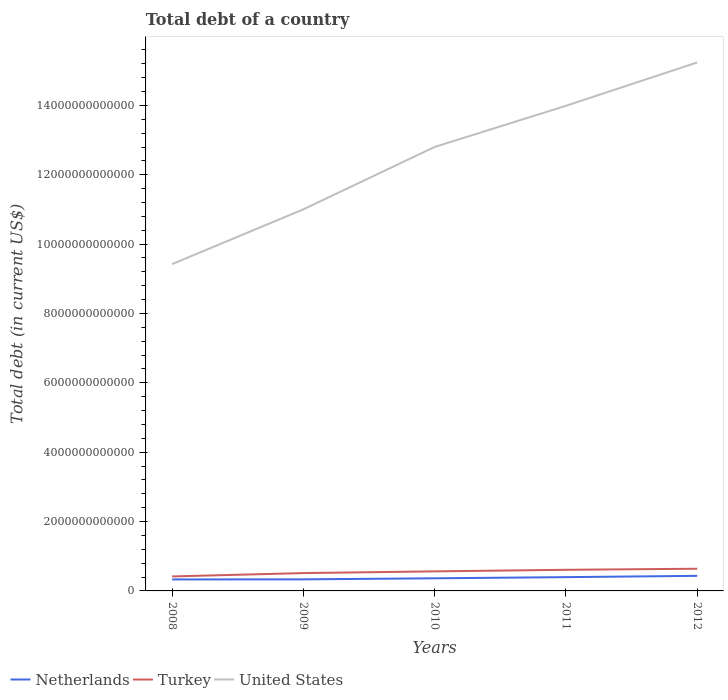How many different coloured lines are there?
Ensure brevity in your answer.  3. Across all years, what is the maximum debt in Netherlands?
Make the answer very short. 3.31e+11. What is the total debt in United States in the graph?
Give a very brief answer. -1.25e+12. What is the difference between the highest and the second highest debt in Netherlands?
Your answer should be very brief. 1.04e+11. How many years are there in the graph?
Ensure brevity in your answer.  5. What is the difference between two consecutive major ticks on the Y-axis?
Ensure brevity in your answer.  2.00e+12. Does the graph contain grids?
Your answer should be compact. No. How many legend labels are there?
Your response must be concise. 3. What is the title of the graph?
Provide a succinct answer. Total debt of a country. What is the label or title of the Y-axis?
Keep it short and to the point. Total debt (in current US$). What is the Total debt (in current US$) of Netherlands in 2008?
Give a very brief answer. 3.31e+11. What is the Total debt (in current US$) of Turkey in 2008?
Your answer should be compact. 4.18e+11. What is the Total debt (in current US$) of United States in 2008?
Your answer should be compact. 9.42e+12. What is the Total debt (in current US$) in Netherlands in 2009?
Your response must be concise. 3.33e+11. What is the Total debt (in current US$) in Turkey in 2009?
Provide a succinct answer. 5.15e+11. What is the Total debt (in current US$) of United States in 2009?
Give a very brief answer. 1.10e+13. What is the Total debt (in current US$) in Netherlands in 2010?
Your answer should be very brief. 3.64e+11. What is the Total debt (in current US$) of Turkey in 2010?
Give a very brief answer. 5.64e+11. What is the Total debt (in current US$) of United States in 2010?
Offer a terse response. 1.28e+13. What is the Total debt (in current US$) in Netherlands in 2011?
Your response must be concise. 3.97e+11. What is the Total debt (in current US$) in Turkey in 2011?
Offer a very short reply. 6.09e+11. What is the Total debt (in current US$) of United States in 2011?
Give a very brief answer. 1.40e+13. What is the Total debt (in current US$) in Netherlands in 2012?
Make the answer very short. 4.35e+11. What is the Total debt (in current US$) in Turkey in 2012?
Provide a succinct answer. 6.40e+11. What is the Total debt (in current US$) of United States in 2012?
Make the answer very short. 1.52e+13. Across all years, what is the maximum Total debt (in current US$) in Netherlands?
Keep it short and to the point. 4.35e+11. Across all years, what is the maximum Total debt (in current US$) of Turkey?
Provide a succinct answer. 6.40e+11. Across all years, what is the maximum Total debt (in current US$) in United States?
Give a very brief answer. 1.52e+13. Across all years, what is the minimum Total debt (in current US$) of Netherlands?
Offer a very short reply. 3.31e+11. Across all years, what is the minimum Total debt (in current US$) of Turkey?
Offer a terse response. 4.18e+11. Across all years, what is the minimum Total debt (in current US$) of United States?
Provide a succinct answer. 9.42e+12. What is the total Total debt (in current US$) of Netherlands in the graph?
Provide a short and direct response. 1.86e+12. What is the total Total debt (in current US$) of Turkey in the graph?
Give a very brief answer. 2.75e+12. What is the total Total debt (in current US$) in United States in the graph?
Ensure brevity in your answer.  6.25e+13. What is the difference between the Total debt (in current US$) in Netherlands in 2008 and that in 2009?
Your answer should be very brief. -1.86e+09. What is the difference between the Total debt (in current US$) of Turkey in 2008 and that in 2009?
Offer a very short reply. -9.67e+1. What is the difference between the Total debt (in current US$) in United States in 2008 and that in 2009?
Give a very brief answer. -1.58e+12. What is the difference between the Total debt (in current US$) in Netherlands in 2008 and that in 2010?
Offer a terse response. -3.28e+1. What is the difference between the Total debt (in current US$) of Turkey in 2008 and that in 2010?
Provide a short and direct response. -1.46e+11. What is the difference between the Total debt (in current US$) of United States in 2008 and that in 2010?
Give a very brief answer. -3.38e+12. What is the difference between the Total debt (in current US$) of Netherlands in 2008 and that in 2011?
Your response must be concise. -6.59e+1. What is the difference between the Total debt (in current US$) of Turkey in 2008 and that in 2011?
Make the answer very short. -1.91e+11. What is the difference between the Total debt (in current US$) of United States in 2008 and that in 2011?
Make the answer very short. -4.56e+12. What is the difference between the Total debt (in current US$) in Netherlands in 2008 and that in 2012?
Keep it short and to the point. -1.04e+11. What is the difference between the Total debt (in current US$) in Turkey in 2008 and that in 2012?
Ensure brevity in your answer.  -2.22e+11. What is the difference between the Total debt (in current US$) in United States in 2008 and that in 2012?
Give a very brief answer. -5.81e+12. What is the difference between the Total debt (in current US$) in Netherlands in 2009 and that in 2010?
Your answer should be very brief. -3.09e+1. What is the difference between the Total debt (in current US$) of Turkey in 2009 and that in 2010?
Offer a terse response. -4.96e+1. What is the difference between the Total debt (in current US$) in United States in 2009 and that in 2010?
Give a very brief answer. -1.80e+12. What is the difference between the Total debt (in current US$) of Netherlands in 2009 and that in 2011?
Your answer should be compact. -6.41e+1. What is the difference between the Total debt (in current US$) in Turkey in 2009 and that in 2011?
Offer a terse response. -9.46e+1. What is the difference between the Total debt (in current US$) in United States in 2009 and that in 2011?
Keep it short and to the point. -2.98e+12. What is the difference between the Total debt (in current US$) in Netherlands in 2009 and that in 2012?
Your answer should be compact. -1.02e+11. What is the difference between the Total debt (in current US$) in Turkey in 2009 and that in 2012?
Your answer should be compact. -1.25e+11. What is the difference between the Total debt (in current US$) in United States in 2009 and that in 2012?
Keep it short and to the point. -4.24e+12. What is the difference between the Total debt (in current US$) in Netherlands in 2010 and that in 2011?
Your answer should be very brief. -3.31e+1. What is the difference between the Total debt (in current US$) of Turkey in 2010 and that in 2011?
Offer a terse response. -4.50e+1. What is the difference between the Total debt (in current US$) of United States in 2010 and that in 2011?
Your response must be concise. -1.19e+12. What is the difference between the Total debt (in current US$) of Netherlands in 2010 and that in 2012?
Give a very brief answer. -7.08e+1. What is the difference between the Total debt (in current US$) in Turkey in 2010 and that in 2012?
Your answer should be compact. -7.55e+1. What is the difference between the Total debt (in current US$) of United States in 2010 and that in 2012?
Offer a terse response. -2.44e+12. What is the difference between the Total debt (in current US$) in Netherlands in 2011 and that in 2012?
Your response must be concise. -3.76e+1. What is the difference between the Total debt (in current US$) in Turkey in 2011 and that in 2012?
Offer a terse response. -3.05e+1. What is the difference between the Total debt (in current US$) of United States in 2011 and that in 2012?
Make the answer very short. -1.25e+12. What is the difference between the Total debt (in current US$) of Netherlands in 2008 and the Total debt (in current US$) of Turkey in 2009?
Provide a short and direct response. -1.83e+11. What is the difference between the Total debt (in current US$) of Netherlands in 2008 and the Total debt (in current US$) of United States in 2009?
Keep it short and to the point. -1.07e+13. What is the difference between the Total debt (in current US$) of Turkey in 2008 and the Total debt (in current US$) of United States in 2009?
Your answer should be very brief. -1.06e+13. What is the difference between the Total debt (in current US$) in Netherlands in 2008 and the Total debt (in current US$) in Turkey in 2010?
Keep it short and to the point. -2.33e+11. What is the difference between the Total debt (in current US$) in Netherlands in 2008 and the Total debt (in current US$) in United States in 2010?
Your answer should be compact. -1.25e+13. What is the difference between the Total debt (in current US$) in Turkey in 2008 and the Total debt (in current US$) in United States in 2010?
Offer a very short reply. -1.24e+13. What is the difference between the Total debt (in current US$) of Netherlands in 2008 and the Total debt (in current US$) of Turkey in 2011?
Your answer should be compact. -2.78e+11. What is the difference between the Total debt (in current US$) of Netherlands in 2008 and the Total debt (in current US$) of United States in 2011?
Make the answer very short. -1.37e+13. What is the difference between the Total debt (in current US$) in Turkey in 2008 and the Total debt (in current US$) in United States in 2011?
Offer a very short reply. -1.36e+13. What is the difference between the Total debt (in current US$) of Netherlands in 2008 and the Total debt (in current US$) of Turkey in 2012?
Ensure brevity in your answer.  -3.08e+11. What is the difference between the Total debt (in current US$) of Netherlands in 2008 and the Total debt (in current US$) of United States in 2012?
Keep it short and to the point. -1.49e+13. What is the difference between the Total debt (in current US$) of Turkey in 2008 and the Total debt (in current US$) of United States in 2012?
Keep it short and to the point. -1.48e+13. What is the difference between the Total debt (in current US$) of Netherlands in 2009 and the Total debt (in current US$) of Turkey in 2010?
Your answer should be compact. -2.31e+11. What is the difference between the Total debt (in current US$) in Netherlands in 2009 and the Total debt (in current US$) in United States in 2010?
Your answer should be very brief. -1.25e+13. What is the difference between the Total debt (in current US$) of Turkey in 2009 and the Total debt (in current US$) of United States in 2010?
Provide a succinct answer. -1.23e+13. What is the difference between the Total debt (in current US$) of Netherlands in 2009 and the Total debt (in current US$) of Turkey in 2011?
Your answer should be compact. -2.76e+11. What is the difference between the Total debt (in current US$) of Netherlands in 2009 and the Total debt (in current US$) of United States in 2011?
Your answer should be compact. -1.37e+13. What is the difference between the Total debt (in current US$) in Turkey in 2009 and the Total debt (in current US$) in United States in 2011?
Your answer should be compact. -1.35e+13. What is the difference between the Total debt (in current US$) of Netherlands in 2009 and the Total debt (in current US$) of Turkey in 2012?
Give a very brief answer. -3.06e+11. What is the difference between the Total debt (in current US$) of Netherlands in 2009 and the Total debt (in current US$) of United States in 2012?
Offer a very short reply. -1.49e+13. What is the difference between the Total debt (in current US$) of Turkey in 2009 and the Total debt (in current US$) of United States in 2012?
Your answer should be compact. -1.47e+13. What is the difference between the Total debt (in current US$) of Netherlands in 2010 and the Total debt (in current US$) of Turkey in 2011?
Offer a terse response. -2.45e+11. What is the difference between the Total debt (in current US$) in Netherlands in 2010 and the Total debt (in current US$) in United States in 2011?
Ensure brevity in your answer.  -1.36e+13. What is the difference between the Total debt (in current US$) of Turkey in 2010 and the Total debt (in current US$) of United States in 2011?
Provide a succinct answer. -1.34e+13. What is the difference between the Total debt (in current US$) in Netherlands in 2010 and the Total debt (in current US$) in Turkey in 2012?
Make the answer very short. -2.75e+11. What is the difference between the Total debt (in current US$) of Netherlands in 2010 and the Total debt (in current US$) of United States in 2012?
Your answer should be compact. -1.49e+13. What is the difference between the Total debt (in current US$) in Turkey in 2010 and the Total debt (in current US$) in United States in 2012?
Your response must be concise. -1.47e+13. What is the difference between the Total debt (in current US$) in Netherlands in 2011 and the Total debt (in current US$) in Turkey in 2012?
Your answer should be compact. -2.42e+11. What is the difference between the Total debt (in current US$) of Netherlands in 2011 and the Total debt (in current US$) of United States in 2012?
Ensure brevity in your answer.  -1.48e+13. What is the difference between the Total debt (in current US$) of Turkey in 2011 and the Total debt (in current US$) of United States in 2012?
Keep it short and to the point. -1.46e+13. What is the average Total debt (in current US$) in Netherlands per year?
Your answer should be compact. 3.72e+11. What is the average Total debt (in current US$) in Turkey per year?
Provide a succinct answer. 5.49e+11. What is the average Total debt (in current US$) of United States per year?
Your answer should be very brief. 1.25e+13. In the year 2008, what is the difference between the Total debt (in current US$) of Netherlands and Total debt (in current US$) of Turkey?
Keep it short and to the point. -8.65e+1. In the year 2008, what is the difference between the Total debt (in current US$) in Netherlands and Total debt (in current US$) in United States?
Your response must be concise. -9.09e+12. In the year 2008, what is the difference between the Total debt (in current US$) of Turkey and Total debt (in current US$) of United States?
Give a very brief answer. -9.01e+12. In the year 2009, what is the difference between the Total debt (in current US$) in Netherlands and Total debt (in current US$) in Turkey?
Keep it short and to the point. -1.81e+11. In the year 2009, what is the difference between the Total debt (in current US$) in Netherlands and Total debt (in current US$) in United States?
Give a very brief answer. -1.07e+13. In the year 2009, what is the difference between the Total debt (in current US$) in Turkey and Total debt (in current US$) in United States?
Provide a short and direct response. -1.05e+13. In the year 2010, what is the difference between the Total debt (in current US$) of Netherlands and Total debt (in current US$) of Turkey?
Offer a terse response. -2.00e+11. In the year 2010, what is the difference between the Total debt (in current US$) of Netherlands and Total debt (in current US$) of United States?
Provide a succinct answer. -1.24e+13. In the year 2010, what is the difference between the Total debt (in current US$) in Turkey and Total debt (in current US$) in United States?
Provide a short and direct response. -1.22e+13. In the year 2011, what is the difference between the Total debt (in current US$) of Netherlands and Total debt (in current US$) of Turkey?
Your answer should be compact. -2.12e+11. In the year 2011, what is the difference between the Total debt (in current US$) of Netherlands and Total debt (in current US$) of United States?
Your answer should be very brief. -1.36e+13. In the year 2011, what is the difference between the Total debt (in current US$) in Turkey and Total debt (in current US$) in United States?
Your response must be concise. -1.34e+13. In the year 2012, what is the difference between the Total debt (in current US$) of Netherlands and Total debt (in current US$) of Turkey?
Your answer should be compact. -2.05e+11. In the year 2012, what is the difference between the Total debt (in current US$) in Netherlands and Total debt (in current US$) in United States?
Ensure brevity in your answer.  -1.48e+13. In the year 2012, what is the difference between the Total debt (in current US$) of Turkey and Total debt (in current US$) of United States?
Provide a succinct answer. -1.46e+13. What is the ratio of the Total debt (in current US$) of Turkey in 2008 to that in 2009?
Your answer should be very brief. 0.81. What is the ratio of the Total debt (in current US$) in United States in 2008 to that in 2009?
Provide a succinct answer. 0.86. What is the ratio of the Total debt (in current US$) of Netherlands in 2008 to that in 2010?
Provide a succinct answer. 0.91. What is the ratio of the Total debt (in current US$) in Turkey in 2008 to that in 2010?
Offer a terse response. 0.74. What is the ratio of the Total debt (in current US$) in United States in 2008 to that in 2010?
Ensure brevity in your answer.  0.74. What is the ratio of the Total debt (in current US$) in Netherlands in 2008 to that in 2011?
Provide a short and direct response. 0.83. What is the ratio of the Total debt (in current US$) of Turkey in 2008 to that in 2011?
Make the answer very short. 0.69. What is the ratio of the Total debt (in current US$) in United States in 2008 to that in 2011?
Provide a succinct answer. 0.67. What is the ratio of the Total debt (in current US$) of Netherlands in 2008 to that in 2012?
Offer a very short reply. 0.76. What is the ratio of the Total debt (in current US$) of Turkey in 2008 to that in 2012?
Your response must be concise. 0.65. What is the ratio of the Total debt (in current US$) of United States in 2008 to that in 2012?
Keep it short and to the point. 0.62. What is the ratio of the Total debt (in current US$) in Netherlands in 2009 to that in 2010?
Give a very brief answer. 0.92. What is the ratio of the Total debt (in current US$) in Turkey in 2009 to that in 2010?
Your answer should be compact. 0.91. What is the ratio of the Total debt (in current US$) in United States in 2009 to that in 2010?
Give a very brief answer. 0.86. What is the ratio of the Total debt (in current US$) of Netherlands in 2009 to that in 2011?
Provide a succinct answer. 0.84. What is the ratio of the Total debt (in current US$) in Turkey in 2009 to that in 2011?
Offer a very short reply. 0.84. What is the ratio of the Total debt (in current US$) of United States in 2009 to that in 2011?
Offer a very short reply. 0.79. What is the ratio of the Total debt (in current US$) of Netherlands in 2009 to that in 2012?
Offer a terse response. 0.77. What is the ratio of the Total debt (in current US$) in Turkey in 2009 to that in 2012?
Provide a succinct answer. 0.8. What is the ratio of the Total debt (in current US$) of United States in 2009 to that in 2012?
Your response must be concise. 0.72. What is the ratio of the Total debt (in current US$) of Netherlands in 2010 to that in 2011?
Your answer should be compact. 0.92. What is the ratio of the Total debt (in current US$) of Turkey in 2010 to that in 2011?
Offer a very short reply. 0.93. What is the ratio of the Total debt (in current US$) in United States in 2010 to that in 2011?
Provide a succinct answer. 0.92. What is the ratio of the Total debt (in current US$) in Netherlands in 2010 to that in 2012?
Offer a very short reply. 0.84. What is the ratio of the Total debt (in current US$) of Turkey in 2010 to that in 2012?
Provide a succinct answer. 0.88. What is the ratio of the Total debt (in current US$) of United States in 2010 to that in 2012?
Your answer should be compact. 0.84. What is the ratio of the Total debt (in current US$) in Netherlands in 2011 to that in 2012?
Make the answer very short. 0.91. What is the ratio of the Total debt (in current US$) of Turkey in 2011 to that in 2012?
Provide a short and direct response. 0.95. What is the ratio of the Total debt (in current US$) in United States in 2011 to that in 2012?
Give a very brief answer. 0.92. What is the difference between the highest and the second highest Total debt (in current US$) of Netherlands?
Offer a very short reply. 3.76e+1. What is the difference between the highest and the second highest Total debt (in current US$) in Turkey?
Provide a succinct answer. 3.05e+1. What is the difference between the highest and the second highest Total debt (in current US$) of United States?
Offer a terse response. 1.25e+12. What is the difference between the highest and the lowest Total debt (in current US$) in Netherlands?
Provide a short and direct response. 1.04e+11. What is the difference between the highest and the lowest Total debt (in current US$) in Turkey?
Provide a short and direct response. 2.22e+11. What is the difference between the highest and the lowest Total debt (in current US$) in United States?
Give a very brief answer. 5.81e+12. 